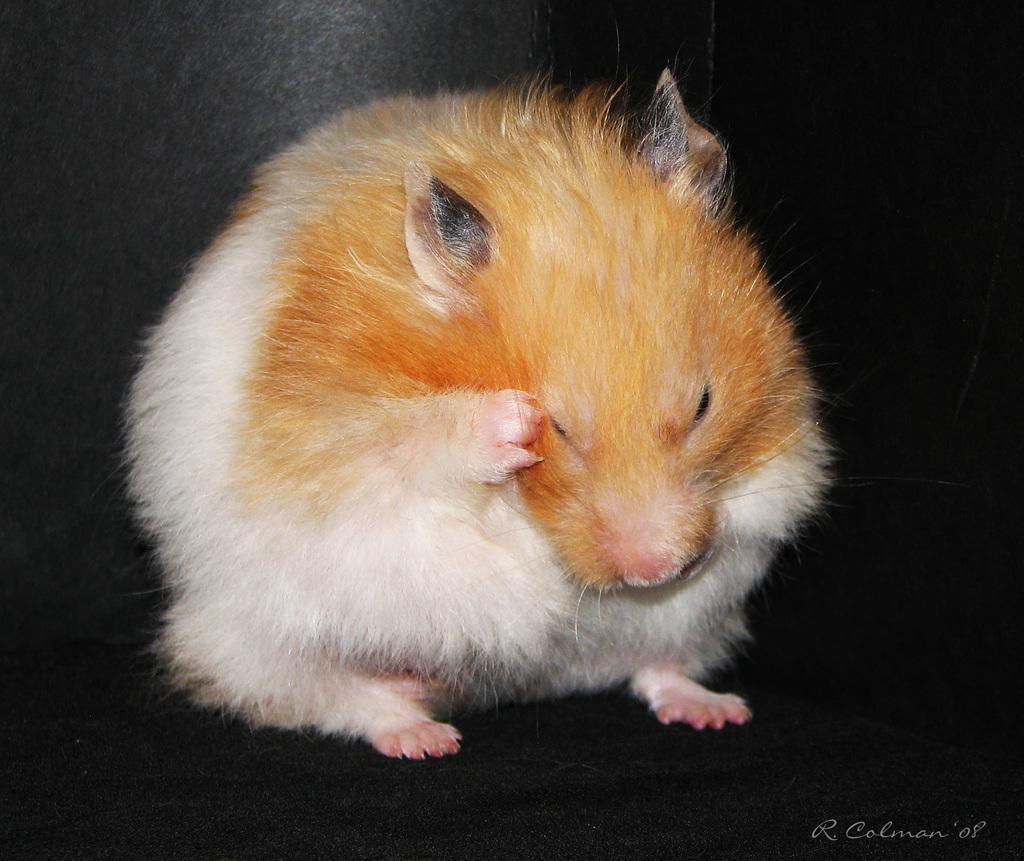What type of animal is in the image? There is a hamster in the image. Can you describe the color pattern of the hamster? The hamster has orange and white colors. What color is the background of the image? The background of the image is black. Is there any text or logo visible in the image? Yes, there is a watermark in the bottom right side of the image. How many feet does the hamster have in the image? Hamsters have four feet, but the number of feet is not directly visible in the image. --- 